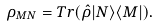Convert formula to latex. <formula><loc_0><loc_0><loc_500><loc_500>\rho _ { M N } = T r ( \hat { \rho } | N \rangle \langle { M } | ) .</formula> 